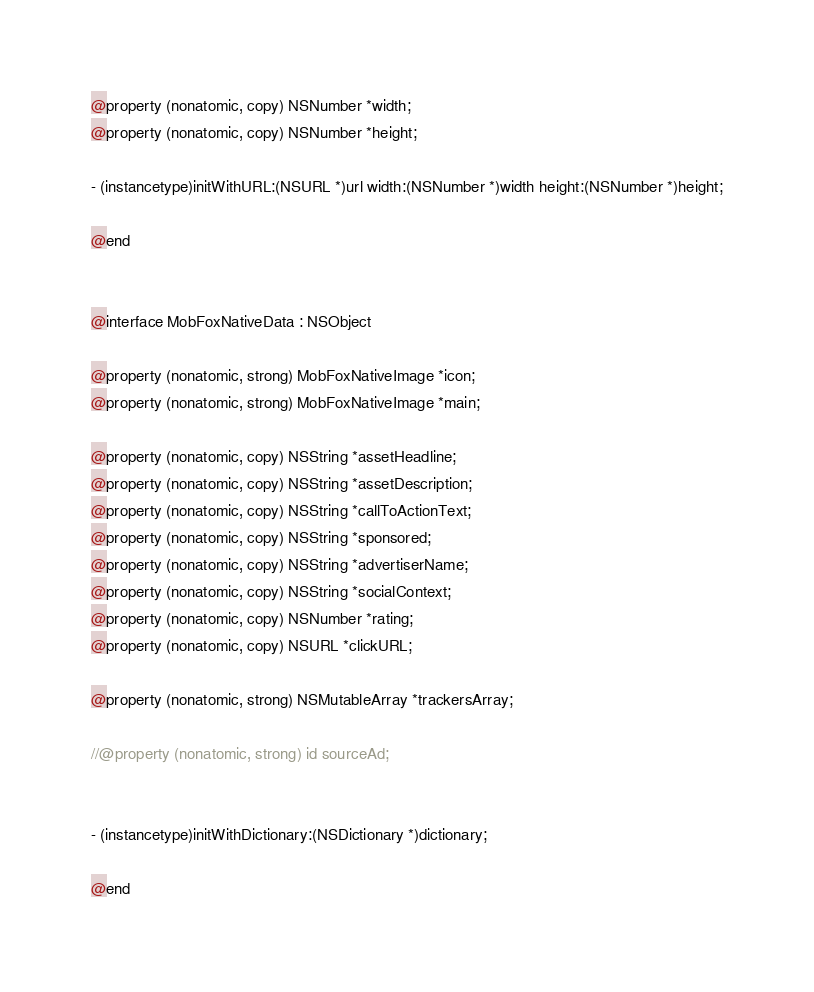Convert code to text. <code><loc_0><loc_0><loc_500><loc_500><_C_>@property (nonatomic, copy) NSNumber *width;
@property (nonatomic, copy) NSNumber *height;

- (instancetype)initWithURL:(NSURL *)url width:(NSNumber *)width height:(NSNumber *)height;

@end


@interface MobFoxNativeData : NSObject

@property (nonatomic, strong) MobFoxNativeImage *icon;
@property (nonatomic, strong) MobFoxNativeImage *main;

@property (nonatomic, copy) NSString *assetHeadline;
@property (nonatomic, copy) NSString *assetDescription;
@property (nonatomic, copy) NSString *callToActionText;
@property (nonatomic, copy) NSString *sponsored;
@property (nonatomic, copy) NSString *advertiserName;
@property (nonatomic, copy) NSString *socialContext;
@property (nonatomic, copy) NSNumber *rating;
@property (nonatomic, copy) NSURL *clickURL;

@property (nonatomic, strong) NSMutableArray *trackersArray;

//@property (nonatomic, strong) id sourceAd;


- (instancetype)initWithDictionary:(NSDictionary *)dictionary;

@end



</code> 